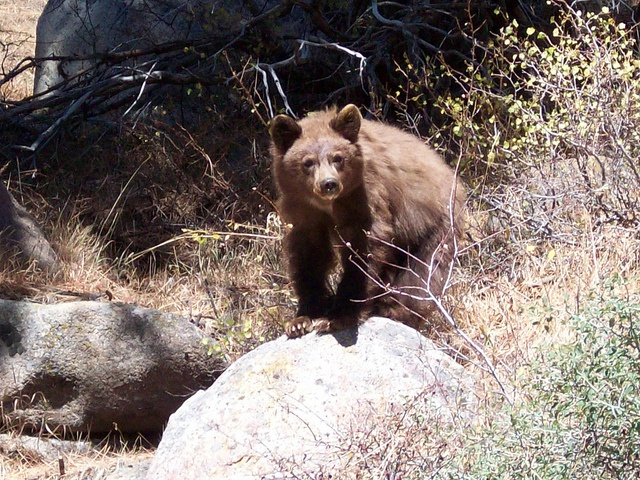Describe the objects in this image and their specific colors. I can see a bear in beige, black, maroon, tan, and gray tones in this image. 